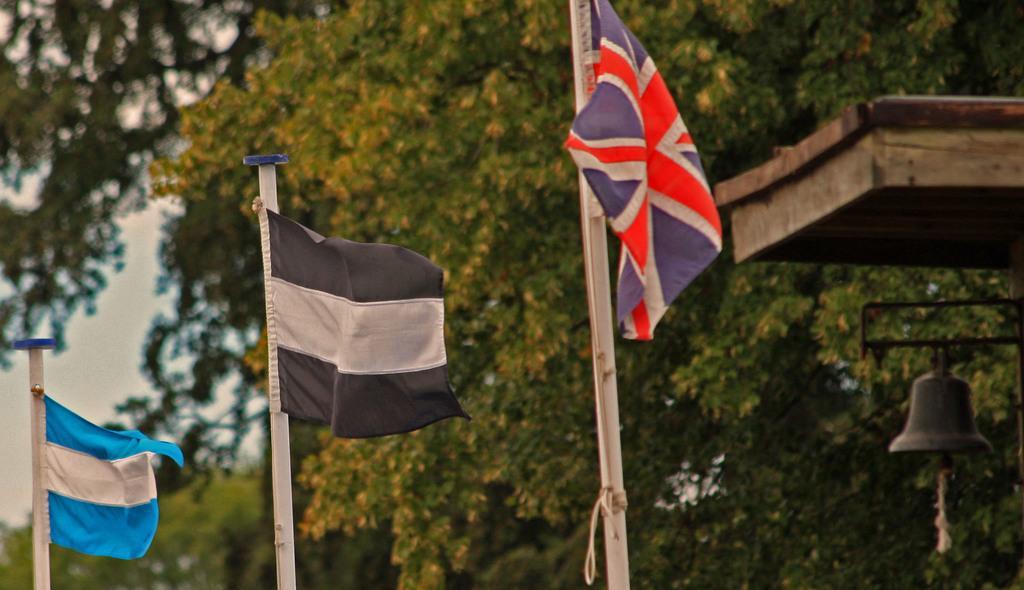In one or two sentences, can you explain what this image depicts? In the image there are three flags and behind the flags there are many trees, on the right side there is a bell. 